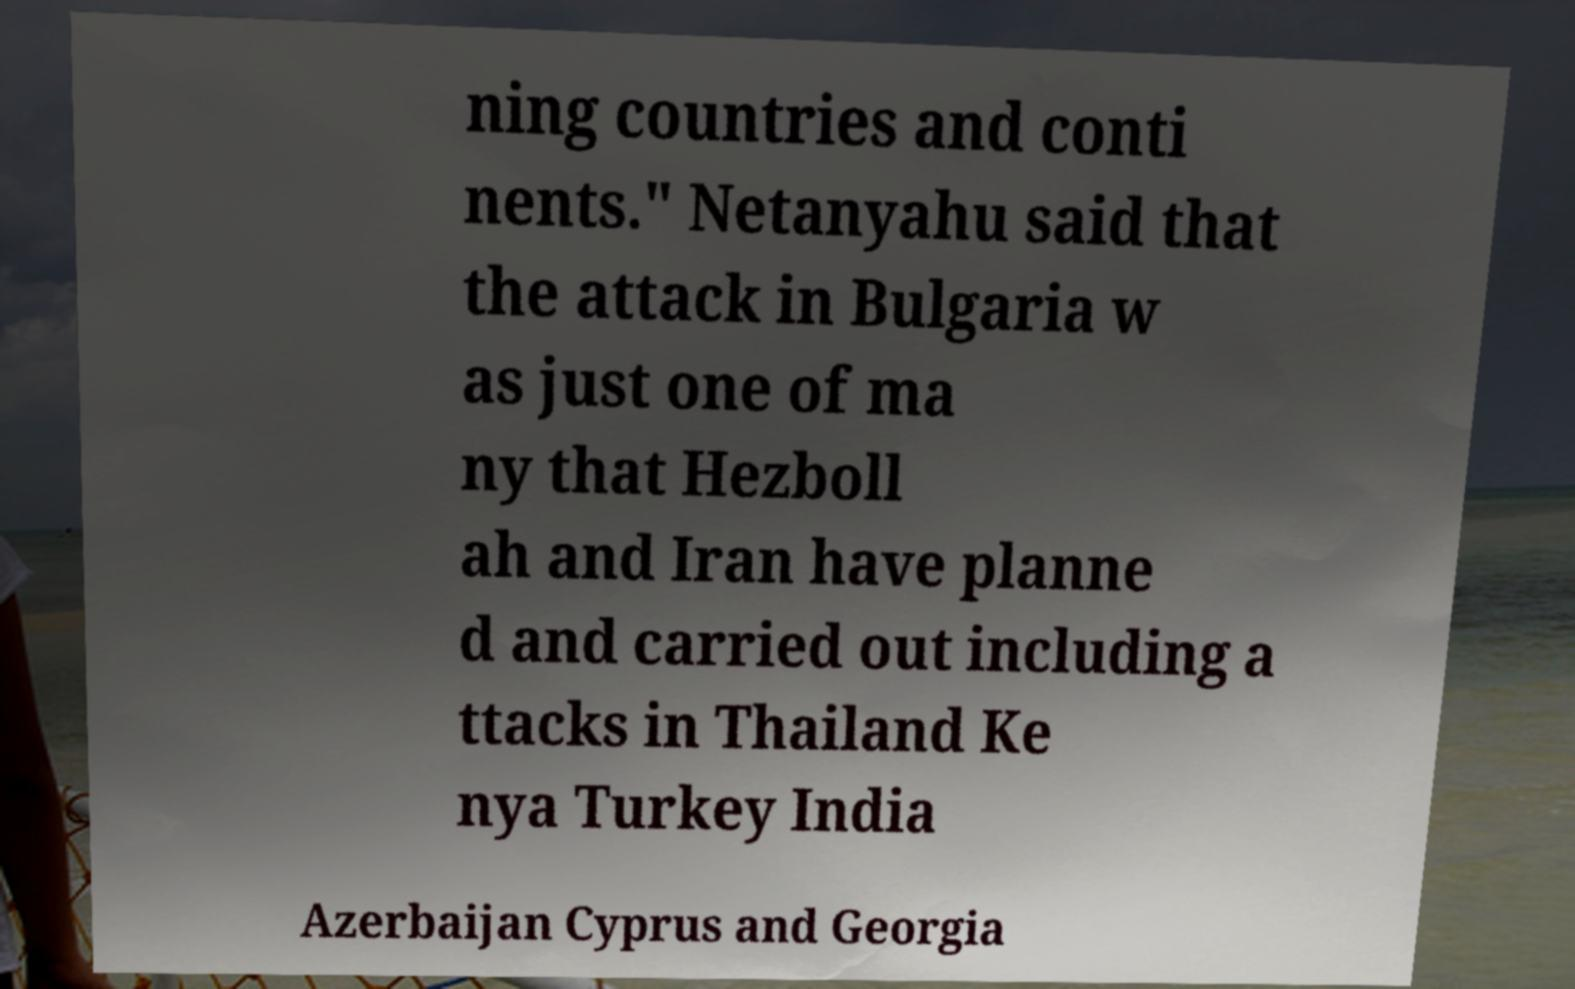I need the written content from this picture converted into text. Can you do that? ning countries and conti nents." Netanyahu said that the attack in Bulgaria w as just one of ma ny that Hezboll ah and Iran have planne d and carried out including a ttacks in Thailand Ke nya Turkey India Azerbaijan Cyprus and Georgia 